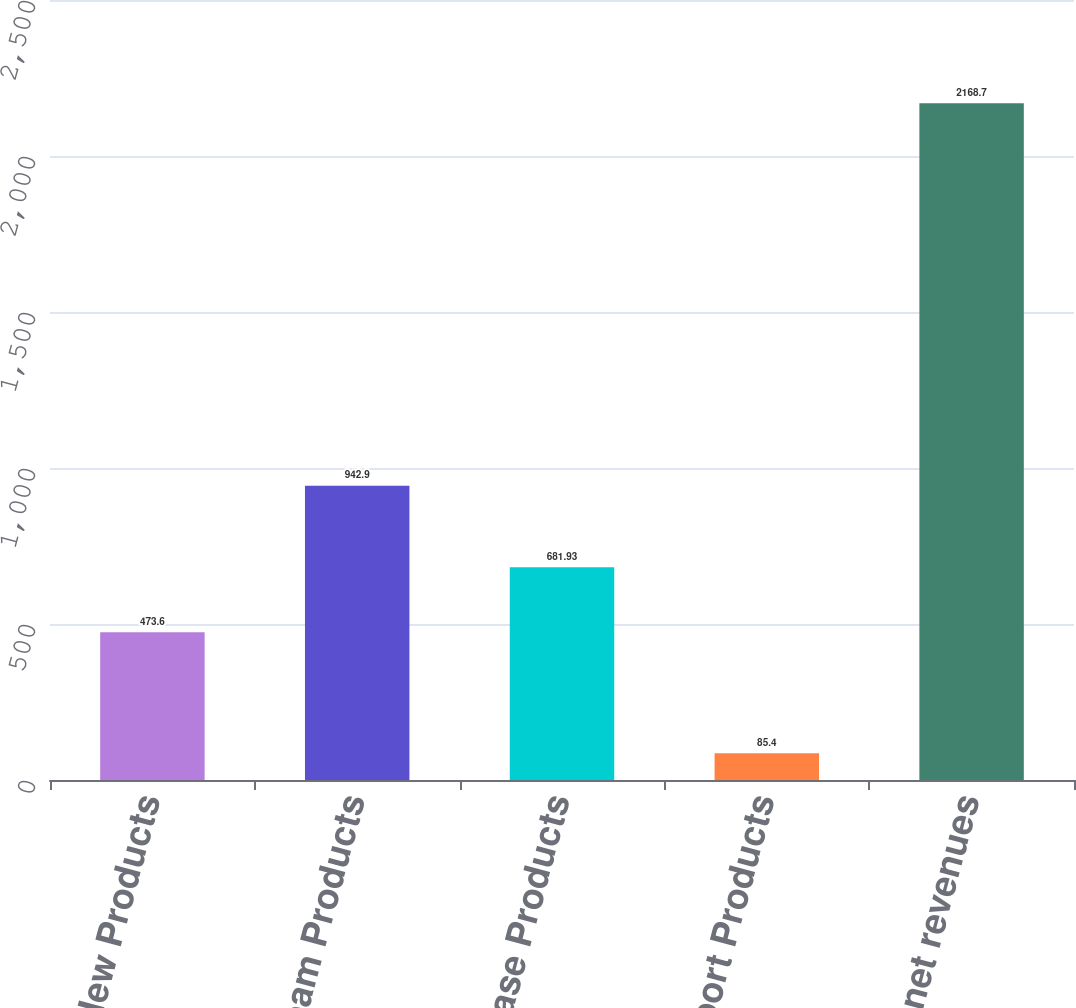<chart> <loc_0><loc_0><loc_500><loc_500><bar_chart><fcel>New Products<fcel>Mainstream Products<fcel>Base Products<fcel>Support Products<fcel>Total net revenues<nl><fcel>473.6<fcel>942.9<fcel>681.93<fcel>85.4<fcel>2168.7<nl></chart> 